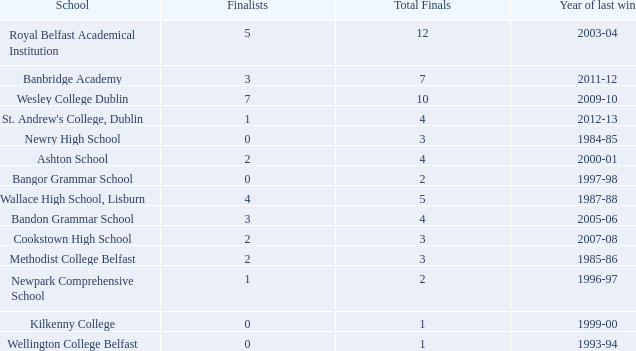Help me parse the entirety of this table. {'header': ['School', 'Finalists', 'Total Finals', 'Year of last win'], 'rows': [['Royal Belfast Academical Institution', '5', '12', '2003-04'], ['Banbridge Academy', '3', '7', '2011-12'], ['Wesley College Dublin', '7', '10', '2009-10'], ["St. Andrew's College, Dublin", '1', '4', '2012-13'], ['Newry High School', '0', '3', '1984-85'], ['Ashton School', '2', '4', '2000-01'], ['Bangor Grammar School', '0', '2', '1997-98'], ['Wallace High School, Lisburn', '4', '5', '1987-88'], ['Bandon Grammar School', '3', '4', '2005-06'], ['Cookstown High School', '2', '3', '2007-08'], ['Methodist College Belfast', '2', '3', '1985-86'], ['Newpark Comprehensive School', '1', '2', '1996-97'], ['Kilkenny College', '0', '1', '1999-00'], ['Wellington College Belfast', '0', '1', '1993-94']]} How many times was banbridge academy the winner? 1.0. 